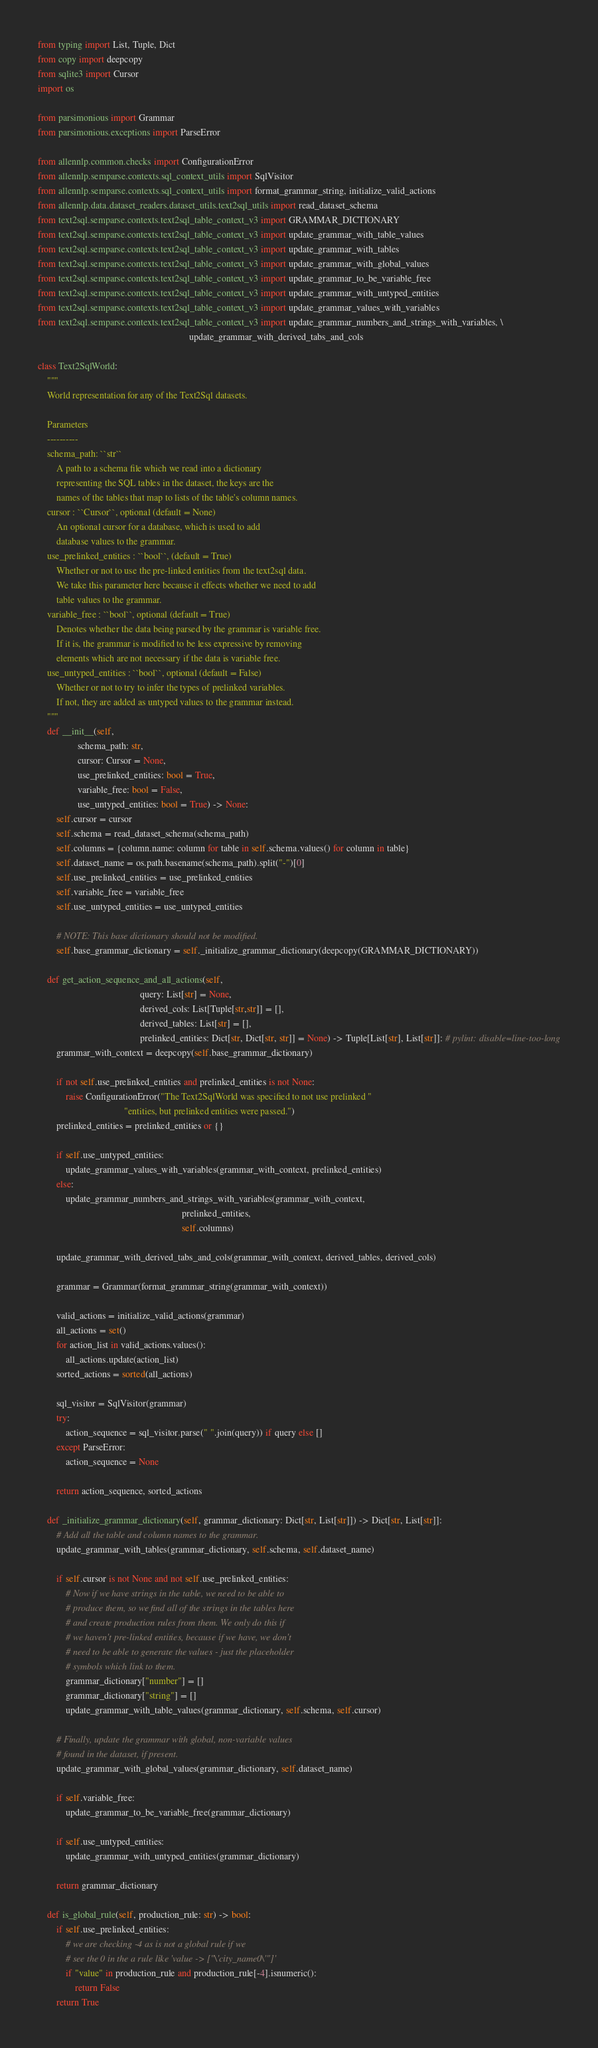<code> <loc_0><loc_0><loc_500><loc_500><_Python_>from typing import List, Tuple, Dict
from copy import deepcopy
from sqlite3 import Cursor
import os

from parsimonious import Grammar
from parsimonious.exceptions import ParseError

from allennlp.common.checks import ConfigurationError
from allennlp.semparse.contexts.sql_context_utils import SqlVisitor
from allennlp.semparse.contexts.sql_context_utils import format_grammar_string, initialize_valid_actions
from allennlp.data.dataset_readers.dataset_utils.text2sql_utils import read_dataset_schema
from text2sql.semparse.contexts.text2sql_table_context_v3 import GRAMMAR_DICTIONARY
from text2sql.semparse.contexts.text2sql_table_context_v3 import update_grammar_with_table_values
from text2sql.semparse.contexts.text2sql_table_context_v3 import update_grammar_with_tables
from text2sql.semparse.contexts.text2sql_table_context_v3 import update_grammar_with_global_values
from text2sql.semparse.contexts.text2sql_table_context_v3 import update_grammar_to_be_variable_free
from text2sql.semparse.contexts.text2sql_table_context_v3 import update_grammar_with_untyped_entities
from text2sql.semparse.contexts.text2sql_table_context_v3 import update_grammar_values_with_variables
from text2sql.semparse.contexts.text2sql_table_context_v3 import update_grammar_numbers_and_strings_with_variables, \
                                                                 update_grammar_with_derived_tabs_and_cols

class Text2SqlWorld:
    """
    World representation for any of the Text2Sql datasets.

    Parameters
    ----------
    schema_path: ``str``
        A path to a schema file which we read into a dictionary
        representing the SQL tables in the dataset, the keys are the
        names of the tables that map to lists of the table's column names.
    cursor : ``Cursor``, optional (default = None)
        An optional cursor for a database, which is used to add
        database values to the grammar.
    use_prelinked_entities : ``bool``, (default = True)
        Whether or not to use the pre-linked entities from the text2sql data.
        We take this parameter here because it effects whether we need to add
        table values to the grammar.
    variable_free : ``bool``, optional (default = True)
        Denotes whether the data being parsed by the grammar is variable free.
        If it is, the grammar is modified to be less expressive by removing
        elements which are not necessary if the data is variable free.
    use_untyped_entities : ``bool``, optional (default = False)
        Whether or not to try to infer the types of prelinked variables.
        If not, they are added as untyped values to the grammar instead.
    """
    def __init__(self,
                 schema_path: str,
                 cursor: Cursor = None,
                 use_prelinked_entities: bool = True,
                 variable_free: bool = False,
                 use_untyped_entities: bool = True) -> None:
        self.cursor = cursor
        self.schema = read_dataset_schema(schema_path)
        self.columns = {column.name: column for table in self.schema.values() for column in table}
        self.dataset_name = os.path.basename(schema_path).split("-")[0]
        self.use_prelinked_entities = use_prelinked_entities
        self.variable_free = variable_free
        self.use_untyped_entities = use_untyped_entities

        # NOTE: This base dictionary should not be modified.
        self.base_grammar_dictionary = self._initialize_grammar_dictionary(deepcopy(GRAMMAR_DICTIONARY))

    def get_action_sequence_and_all_actions(self,
                                            query: List[str] = None,
                                            derived_cols: List[Tuple[str,str]] = [],
                                            derived_tables: List[str] = [],
                                            prelinked_entities: Dict[str, Dict[str, str]] = None) -> Tuple[List[str], List[str]]: # pylint: disable=line-too-long
        grammar_with_context = deepcopy(self.base_grammar_dictionary)

        if not self.use_prelinked_entities and prelinked_entities is not None:
            raise ConfigurationError("The Text2SqlWorld was specified to not use prelinked "
                                     "entities, but prelinked entities were passed.")
        prelinked_entities = prelinked_entities or {}

        if self.use_untyped_entities:
            update_grammar_values_with_variables(grammar_with_context, prelinked_entities)
        else:
            update_grammar_numbers_and_strings_with_variables(grammar_with_context,
                                                              prelinked_entities,
                                                              self.columns)

        update_grammar_with_derived_tabs_and_cols(grammar_with_context, derived_tables, derived_cols)

        grammar = Grammar(format_grammar_string(grammar_with_context))

        valid_actions = initialize_valid_actions(grammar)
        all_actions = set()
        for action_list in valid_actions.values():
            all_actions.update(action_list)
        sorted_actions = sorted(all_actions)

        sql_visitor = SqlVisitor(grammar)
        try:
            action_sequence = sql_visitor.parse(" ".join(query)) if query else []
        except ParseError:
            action_sequence = None

        return action_sequence, sorted_actions

    def _initialize_grammar_dictionary(self, grammar_dictionary: Dict[str, List[str]]) -> Dict[str, List[str]]:
        # Add all the table and column names to the grammar.
        update_grammar_with_tables(grammar_dictionary, self.schema, self.dataset_name)

        if self.cursor is not None and not self.use_prelinked_entities:
            # Now if we have strings in the table, we need to be able to
            # produce them, so we find all of the strings in the tables here
            # and create production rules from them. We only do this if
            # we haven't pre-linked entities, because if we have, we don't
            # need to be able to generate the values - just the placeholder
            # symbols which link to them.
            grammar_dictionary["number"] = []
            grammar_dictionary["string"] = []
            update_grammar_with_table_values(grammar_dictionary, self.schema, self.cursor)

        # Finally, update the grammar with global, non-variable values
        # found in the dataset, if present.
        update_grammar_with_global_values(grammar_dictionary, self.dataset_name)

        if self.variable_free:
            update_grammar_to_be_variable_free(grammar_dictionary)

        if self.use_untyped_entities:
            update_grammar_with_untyped_entities(grammar_dictionary)

        return grammar_dictionary

    def is_global_rule(self, production_rule: str) -> bool:
        if self.use_prelinked_entities:
            # we are checking -4 as is not a global rule if we
            # see the 0 in the a rule like 'value -> ["\'city_name0\'"]'
            if "value" in production_rule and production_rule[-4].isnumeric():
                return False
        return True
</code> 